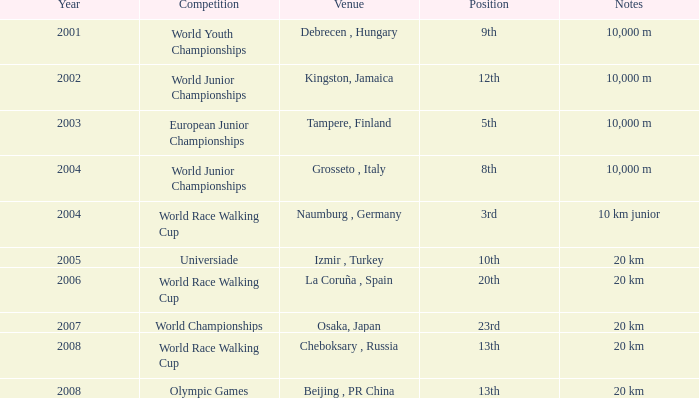In which venue did he place 3rd in the World Race Walking Cup? Naumburg , Germany. 